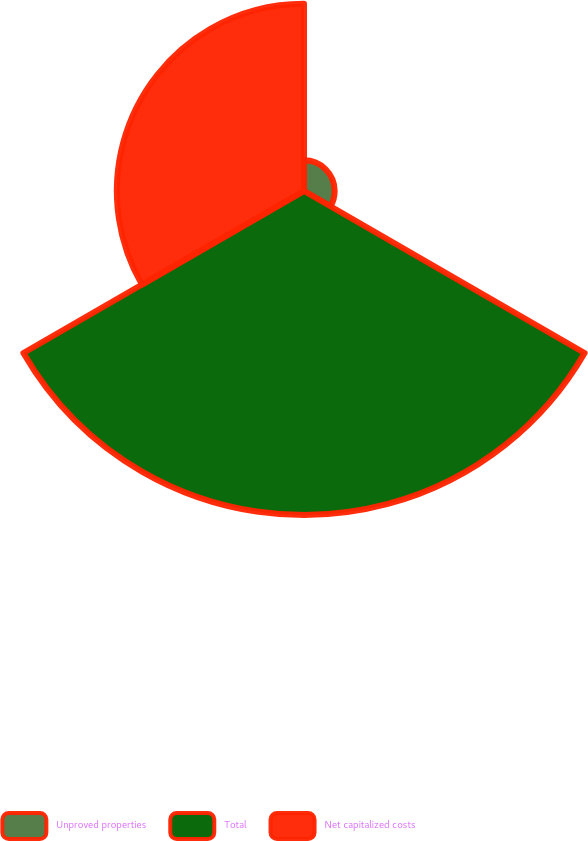<chart> <loc_0><loc_0><loc_500><loc_500><pie_chart><fcel>Unproved properties<fcel>Total<fcel>Net capitalized costs<nl><fcel>5.66%<fcel>59.8%<fcel>34.54%<nl></chart> 